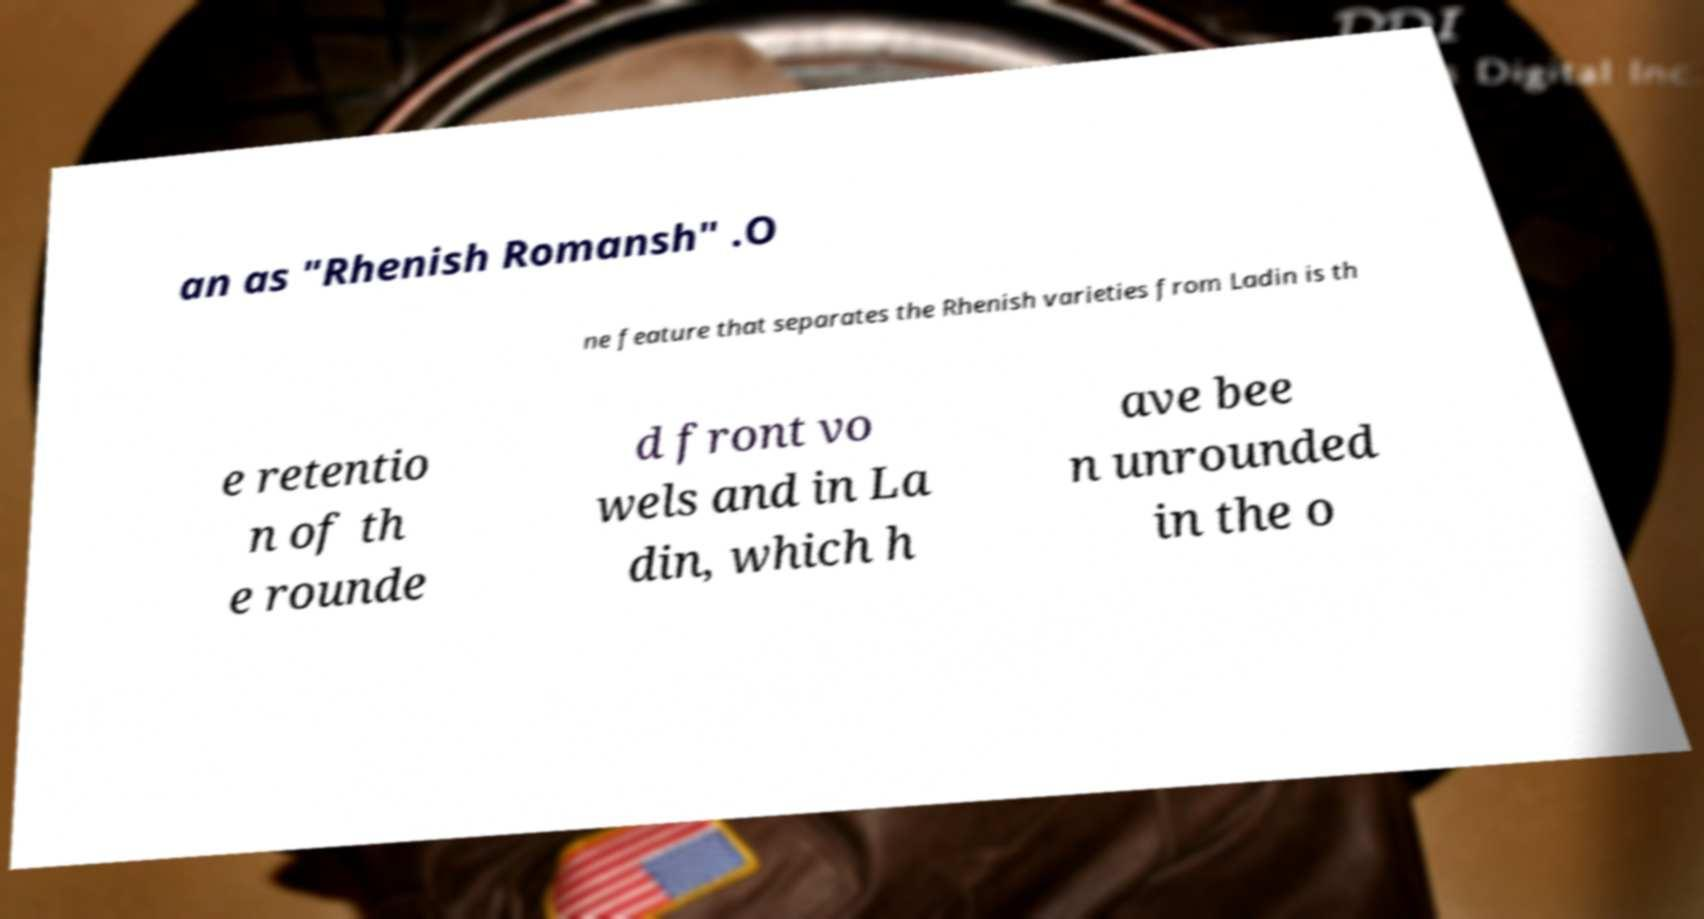Can you accurately transcribe the text from the provided image for me? an as "Rhenish Romansh" .O ne feature that separates the Rhenish varieties from Ladin is th e retentio n of th e rounde d front vo wels and in La din, which h ave bee n unrounded in the o 